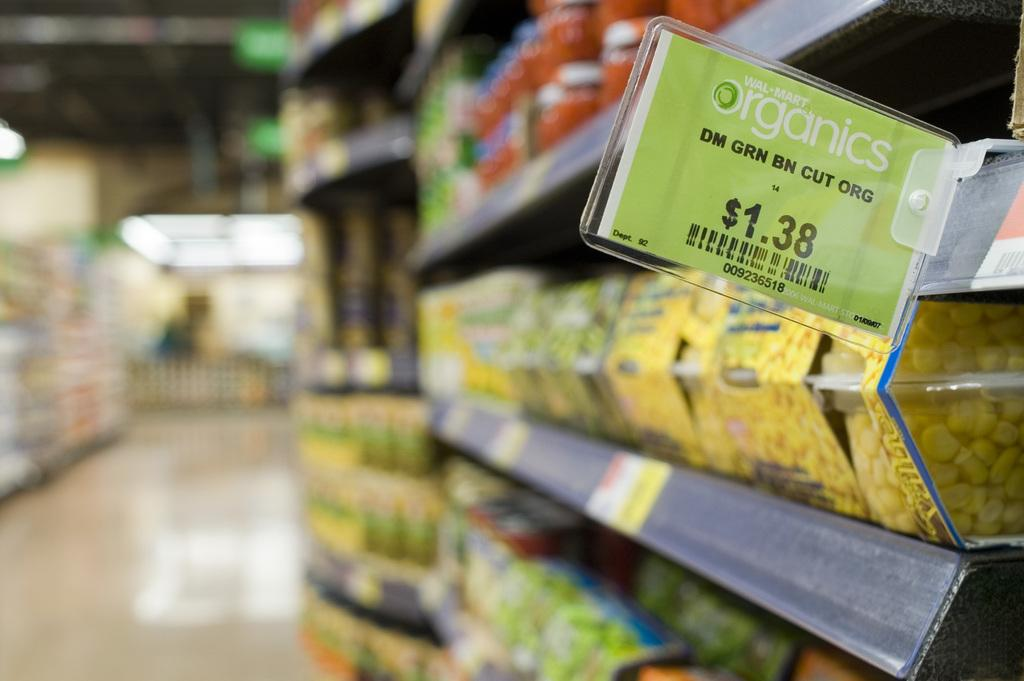<image>
Summarize the visual content of the image. A sign in a market shows that organic cut green beans sell for $1.38. 